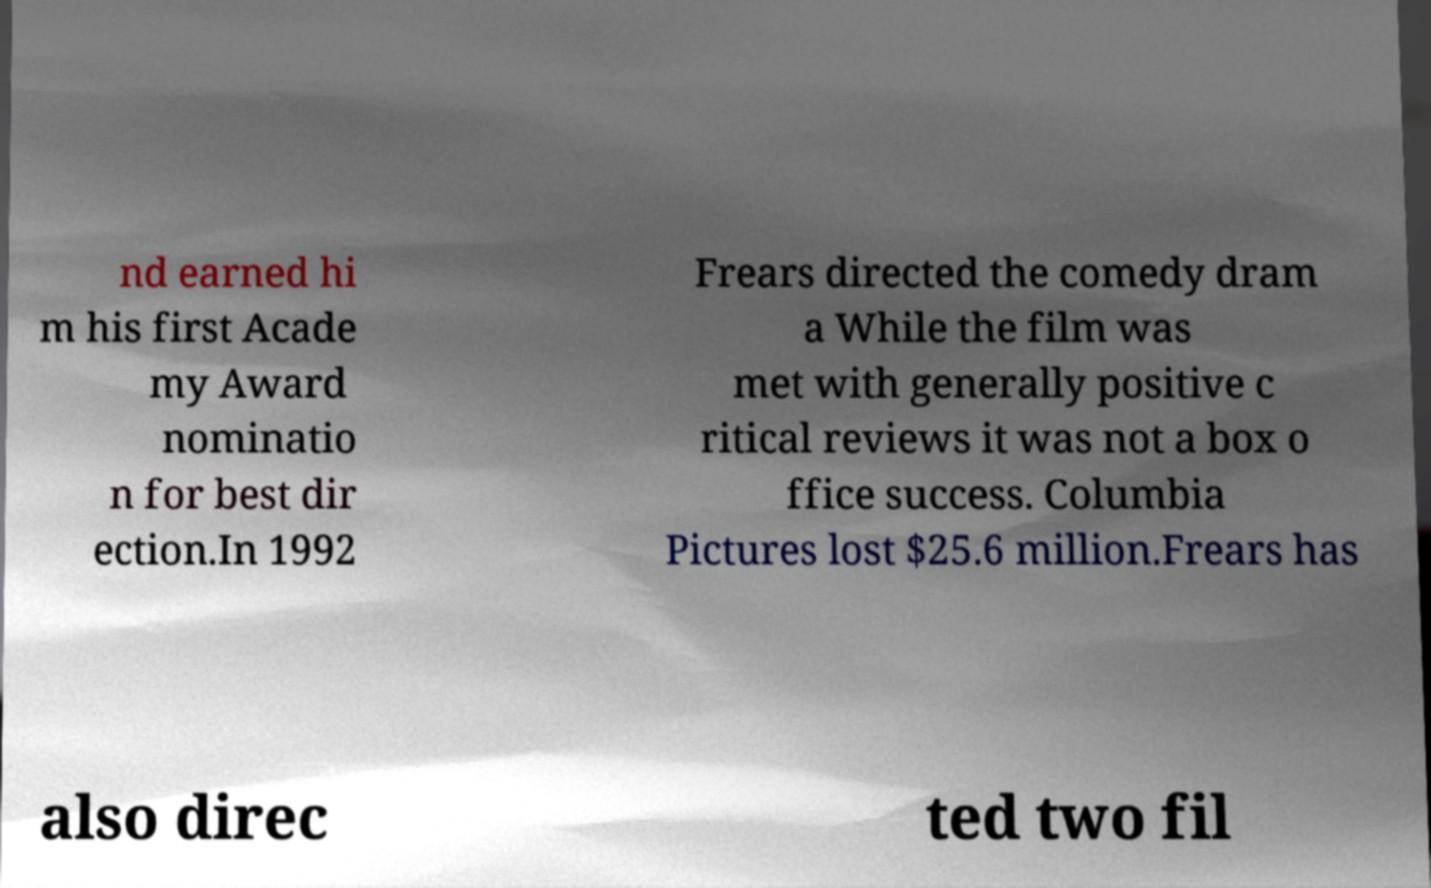Please read and relay the text visible in this image. What does it say? nd earned hi m his first Acade my Award nominatio n for best dir ection.In 1992 Frears directed the comedy dram a While the film was met with generally positive c ritical reviews it was not a box o ffice success. Columbia Pictures lost $25.6 million.Frears has also direc ted two fil 